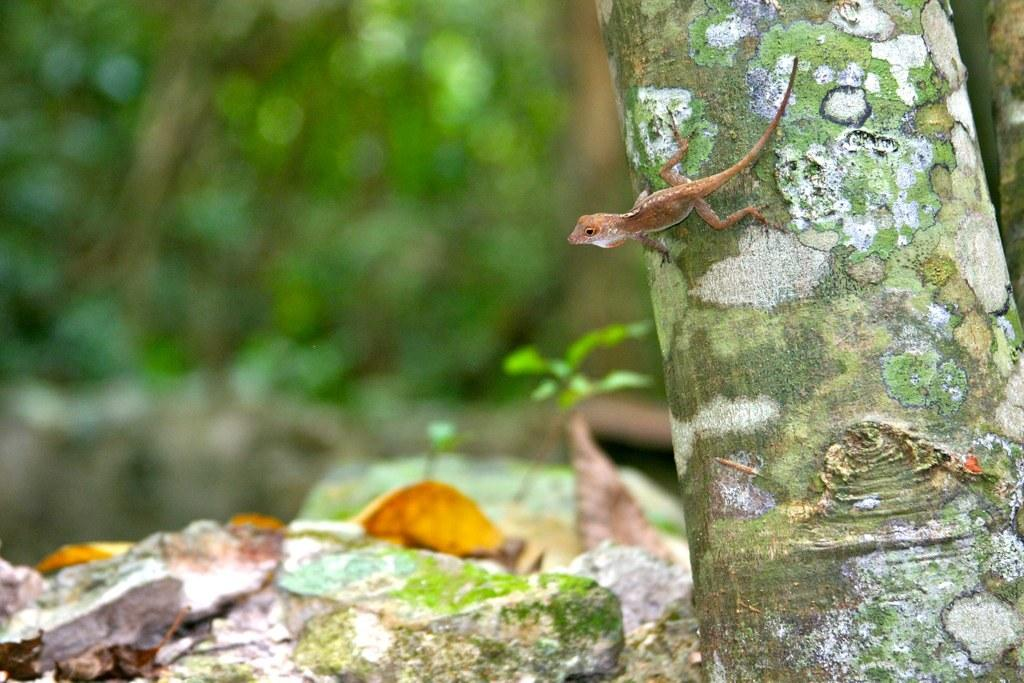What animal can be seen on the tree in the image? There is a lizard on the trunk of a tree in the image. What type of natural features are present in the image? There are rocks and plants in the image. How would you describe the background of the image? The background of the image is blurred. What type of humor can be seen in the lizard's expression in the image? There is no indication of humor or expression in the lizard's appearance in the image. 